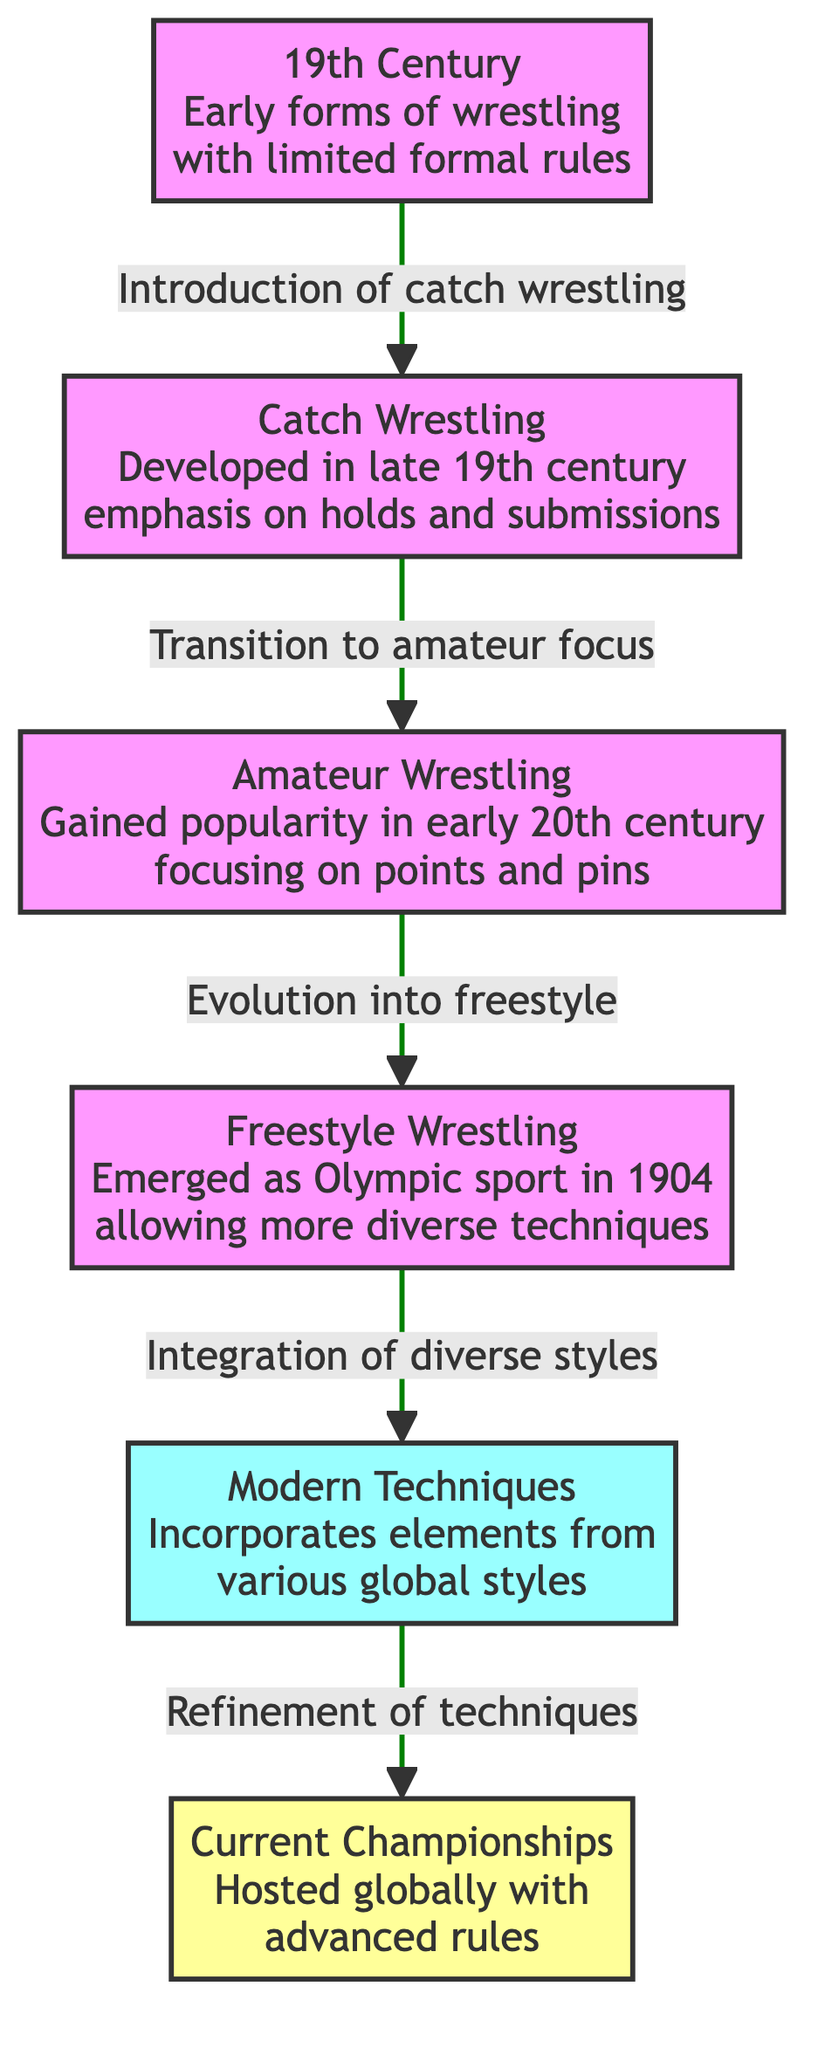What's the first wrestling style mentioned in the diagram? The diagram begins with "19th Century Early forms of wrestling with limited formal rules," which is the first node, indicating it is the initial wrestling style discussed.
Answer: 19th Century How many nodes are present in the diagram? The diagram contains a total of 6 nodes, which represents different wrestling techniques through various historical periods.
Answer: 6 What connects "Catch Wrestling" and "Amateur Wrestling"? The connection between these two nodes is described by the transition marked as "Transition to amateur focus," indicating that Catch Wrestling influenced the development of Amateur Wrestling.
Answer: Transition to amateur focus What style of wrestling emerged as an Olympic sport in 1904? According to the diagram, "Freestyle Wrestling" is stated to have emerged as an Olympic sport in 1904, making it the relevant style for this question.
Answer: Freestyle Wrestling How many stages of evolution are shown between the first and the last node? The flow from the first node "19th Century" to the last node "Current Championships" illustrates 5 distinct stages of evolution of wrestling techniques.
Answer: 5 What is the final focus of the diagram noted in "Current Championships"? The final focus mentioned in the last node is about "advanced rules," which describes the nature of current wrestling championships hosted globally.
Answer: advanced rules What type of techniques are incorporated in "Modern Techniques"? The description for "Modern Techniques" states they incorporate elements from various global styles, indicating the diversity and complexity of techniques in modern wrestling.
Answer: various global styles What directly precedes "Integration of diverse styles"? The diagram shows that "Evolution into freestyle" directly precedes the node for "Integration of diverse styles," showing a progression in the techniques of wrestling.
Answer: Evolution into freestyle What historical development led to "Freestyle Wrestling"? The development leading to "Freestyle Wrestling" is indicated by the evolution from "Amateur Wrestling," therefore, it signifies a major historical transition in wrestling techniques.
Answer: Amateur Wrestling 